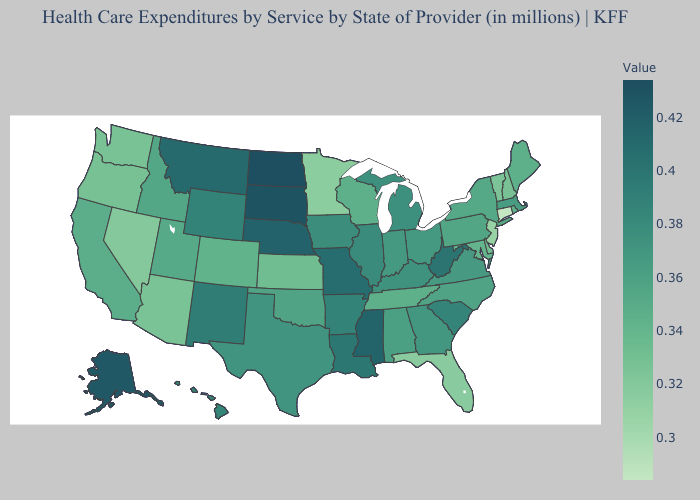Which states have the lowest value in the MidWest?
Be succinct. Minnesota. Does Michigan have the lowest value in the MidWest?
Keep it brief. No. Does Nevada have the lowest value in the West?
Concise answer only. Yes. 